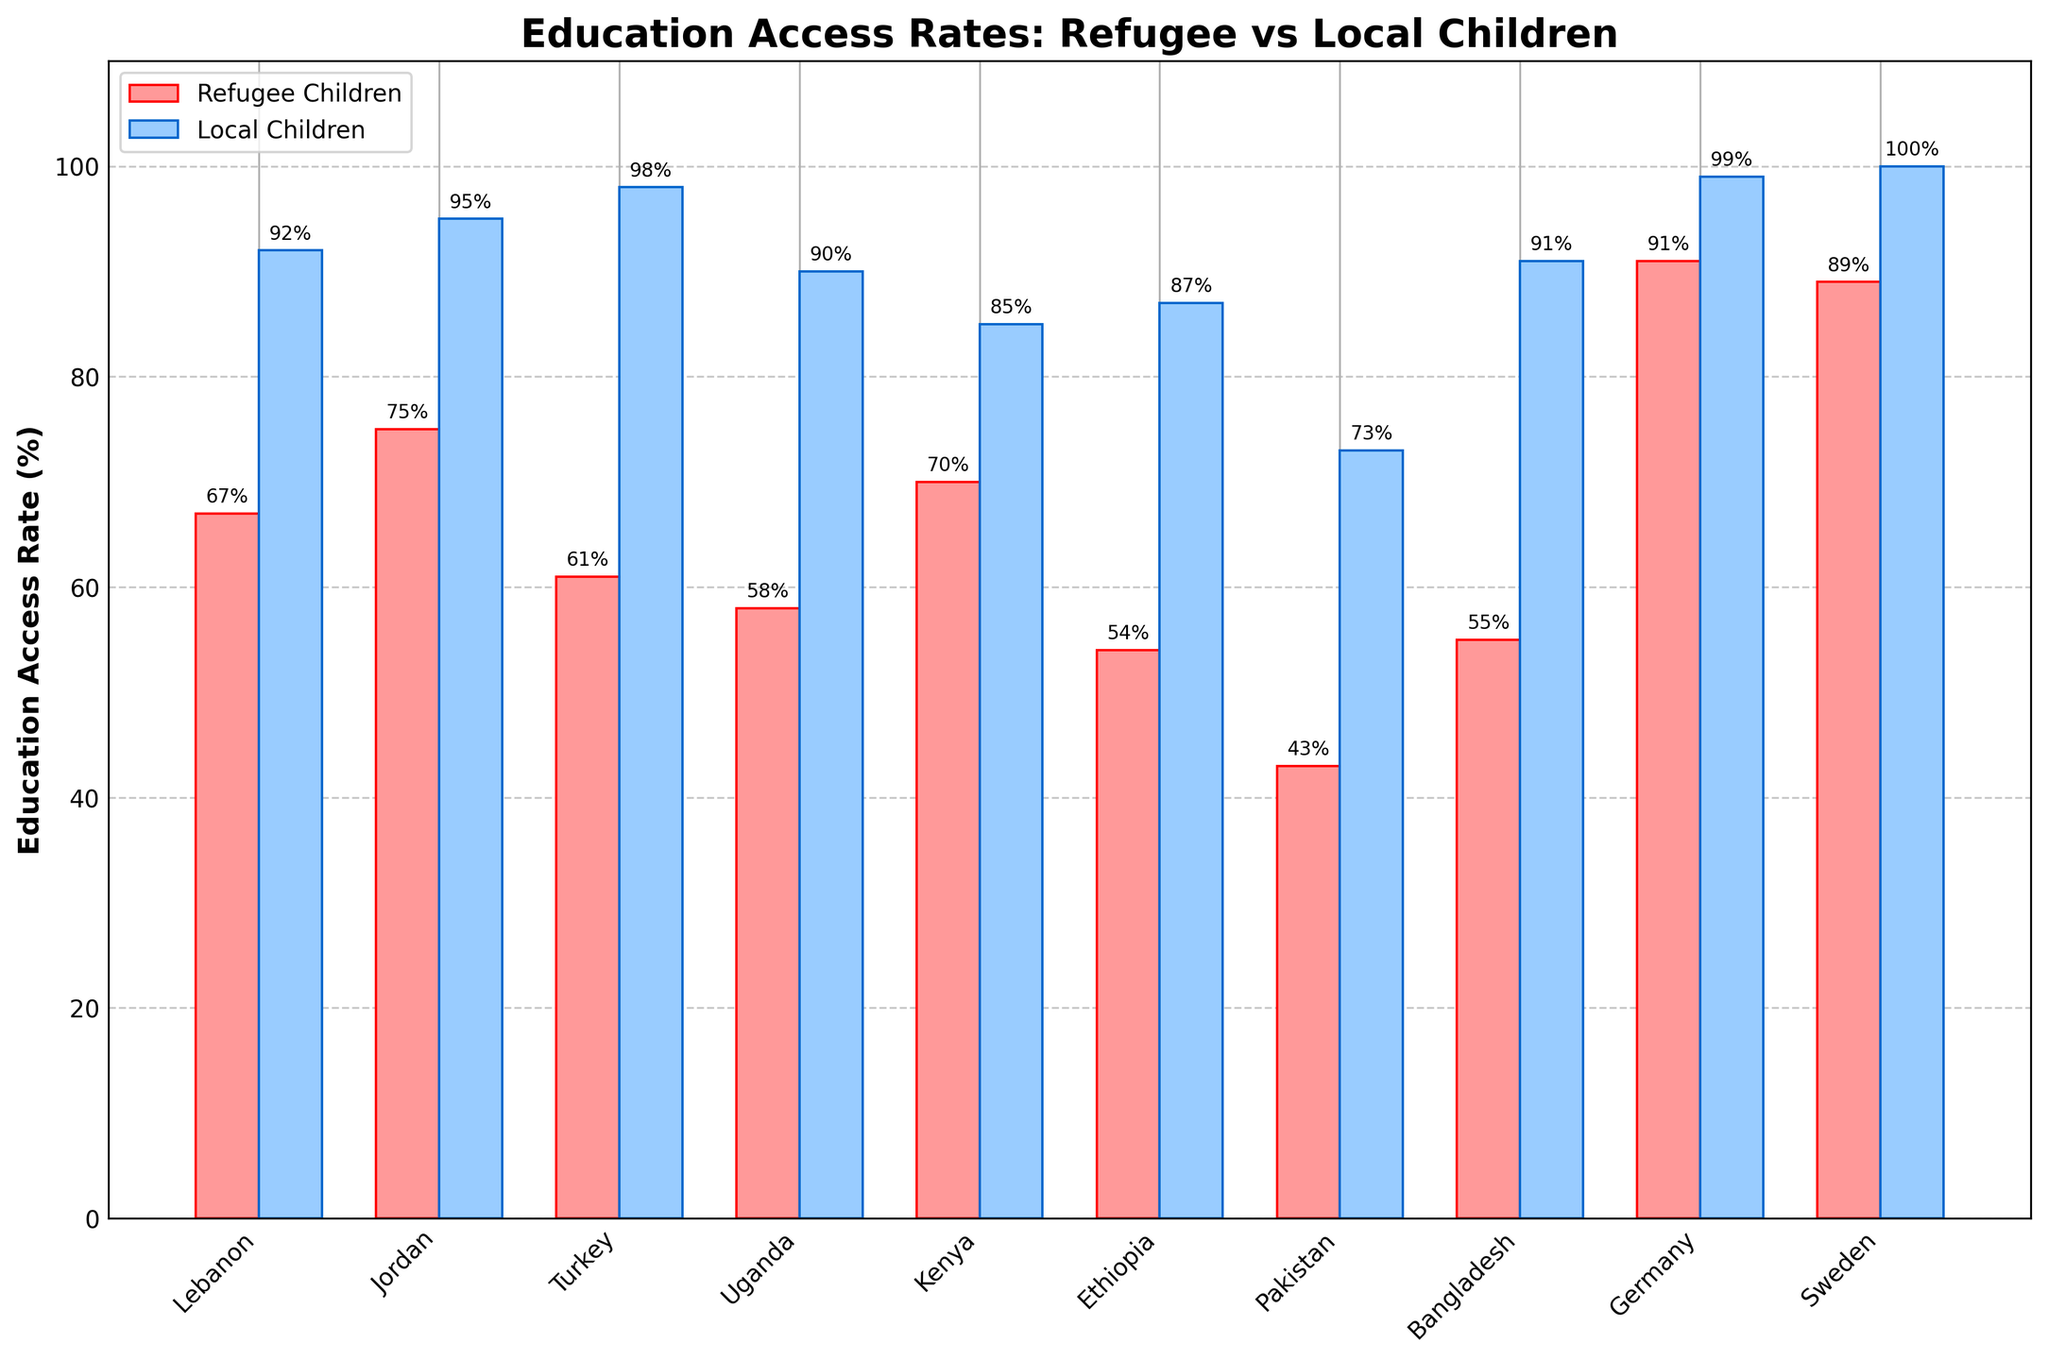How many countries have an education access rate for refugee children greater than 60%? First, identify the countries where the bar for refugee children exceeds 60%. These countries are Lebanon, Jordan, Turkey, Kenya, Bangladesh, Germany, and Sweden. Count these countries.
Answer: 7 What is the difference in education access rates for refugee and local children in Uganda? Look at the heights of the bars for Uganda. The refugee children have 58% and local children have 90%. Subtract these two values: 90 - 58.
Answer: 32 Which country shows the smallest difference in education access rates between refugee and local children? Calculate the differences for each country and find the smallest difference. The differences are: Lebanon (25), Jordan (20), Turkey (37), Uganda (32), Kenya (15), Ethiopia (33), Pakistan (30), Bangladesh (36), Germany (8), Sweden (11). The smallest difference is in Germany.
Answer: Germany What is the average education access rate for local children in Turkey and Jordan? Identify the education access rates for local children in Turkey (98%) and Jordan (95%). Compute the average: (98 + 95) / 2.
Answer: 96.5 Which country has the highest education access rate for refugee children? Look at the heights of the bars for refugee children and find the tallest one. Germany shows the highest rate with 91%.
Answer: Germany Compare the education access rates for refugee children in Pakistan and Ethiopia. Which is lower? Look at the heights of the bars for refugee children in Pakistan and Ethiopia. Pakistan has 43% and Ethiopia has 54%. The lower rate is in Pakistan.
Answer: Pakistan How many countries have an education access rate for local children that is at least 90%? Identify the countries with local children education access rates of 90% or more. These countries are Lebanon, Jordan, Turkey, Uganda, Bangladesh, Germany, and Sweden. Count these countries.
Answer: 7 What is the sum of the education access rates for refugee children in Kenya and Lebanon? Identify the education access rates for refugee children in Kenya (70%) and Lebanon (67%). Sum these two values: 67 + 70.
Answer: 137 